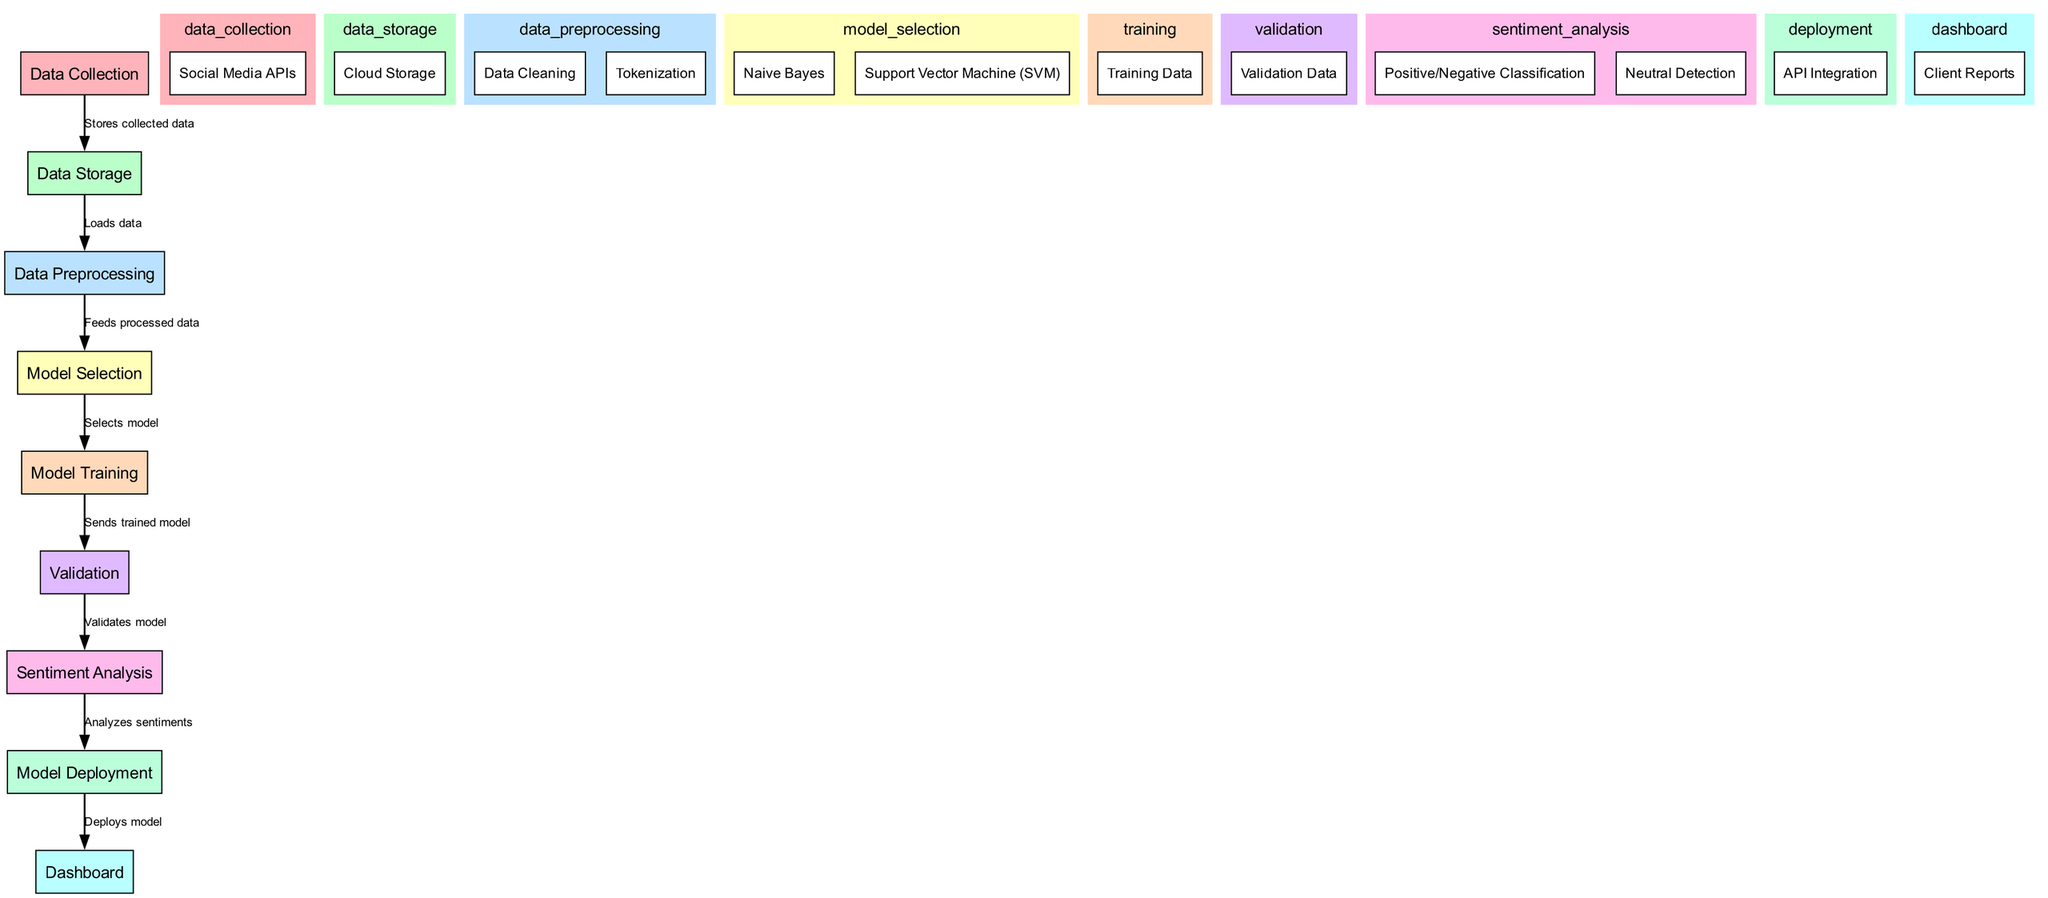What is the first step in the process? The first step in the process is "Data Collection," which is the starting point for fetching social media data.
Answer: Data Collection How many main processes are there in the diagram? The diagram outlines six main processes: Data Collection, Data Storage, Data Preprocessing, Model Selection, Training, Validation, Sentiment Analysis, Deployment, and Dashboard. Counting each phase gives a total of eight.
Answer: Eight What type of analysis is performed after the validation process? After the validation process, "Sentiment Analysis" is performed, which involves analyzing the sentiments of user comments on social media posts.
Answer: Sentiment Analysis Which model is associated with the training process? "Naive Bayes" and "Support Vector Machine (SVM)" are the models associated with the training process, as indicated in the Model Selection phase.
Answer: Naive Bayes, Support Vector Machine What is the purpose of "API Integration" in the deployment phase? "API Integration" is part of the deployment phase, and its purpose is to integrate the sentiment analysis model with other systems, allowing for real-time access to the analysis results.
Answer: Integrate the model What identifies the relationship between "Data Storage" and "Data Preprocessing"? The relationship between "Data Storage" and "Data Preprocessing" is that "Data Storage" loads data into the preprocessing phase, essentially transferring the collected data for further processing.
Answer: Loads data What is the final output of the process as shown in the diagram? The final output of the process is the "Dashboard," which provides the results of the sentiment analysis to stakeholders through visualization and reporting tools.
Answer: Dashboard Which component is responsible for generating client reports? The component responsible for generating client reports is "Client Reports," which is part of the Dashboard section, focusing on the presentation of the analysis results to clients.
Answer: Client Reports What nodes are part of the sentiment analysis process? The nodes that are part of the sentiment analysis process include "Positive/Negative Classification" and "Neutral Detection," both of which classify the sentiments extracted from comments.
Answer: Positive/Negative Classification, Neutral Detection 